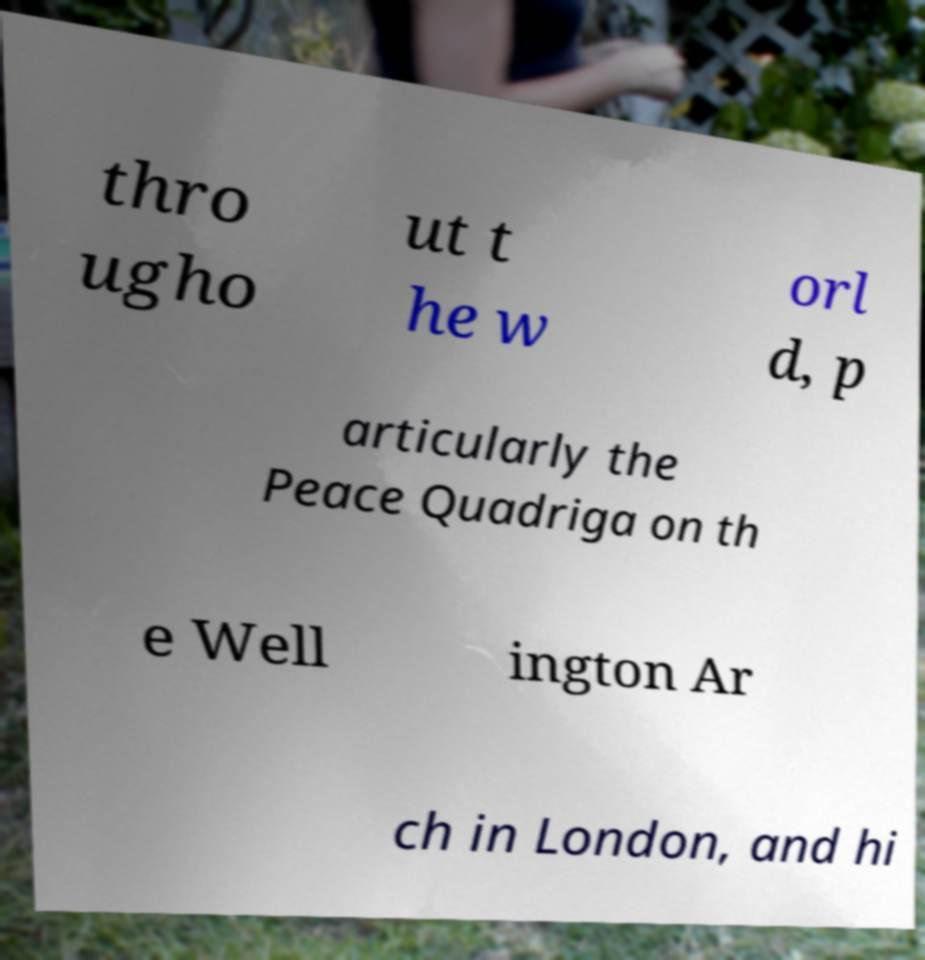There's text embedded in this image that I need extracted. Can you transcribe it verbatim? thro ugho ut t he w orl d, p articularly the Peace Quadriga on th e Well ington Ar ch in London, and hi 